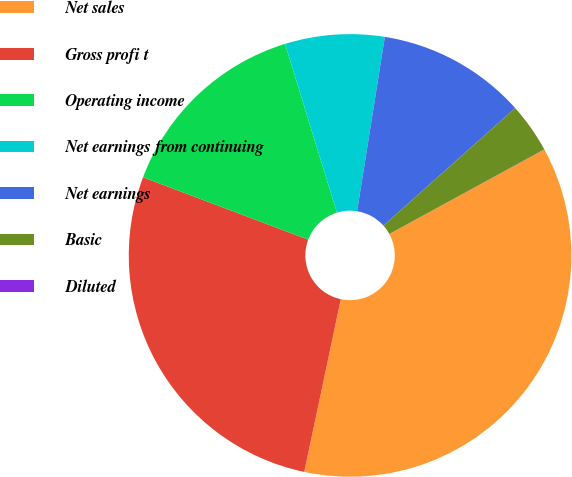<chart> <loc_0><loc_0><loc_500><loc_500><pie_chart><fcel>Net sales<fcel>Gross profi t<fcel>Operating income<fcel>Net earnings from continuing<fcel>Net earnings<fcel>Basic<fcel>Diluted<nl><fcel>36.27%<fcel>27.42%<fcel>14.51%<fcel>7.26%<fcel>10.89%<fcel>3.64%<fcel>0.01%<nl></chart> 